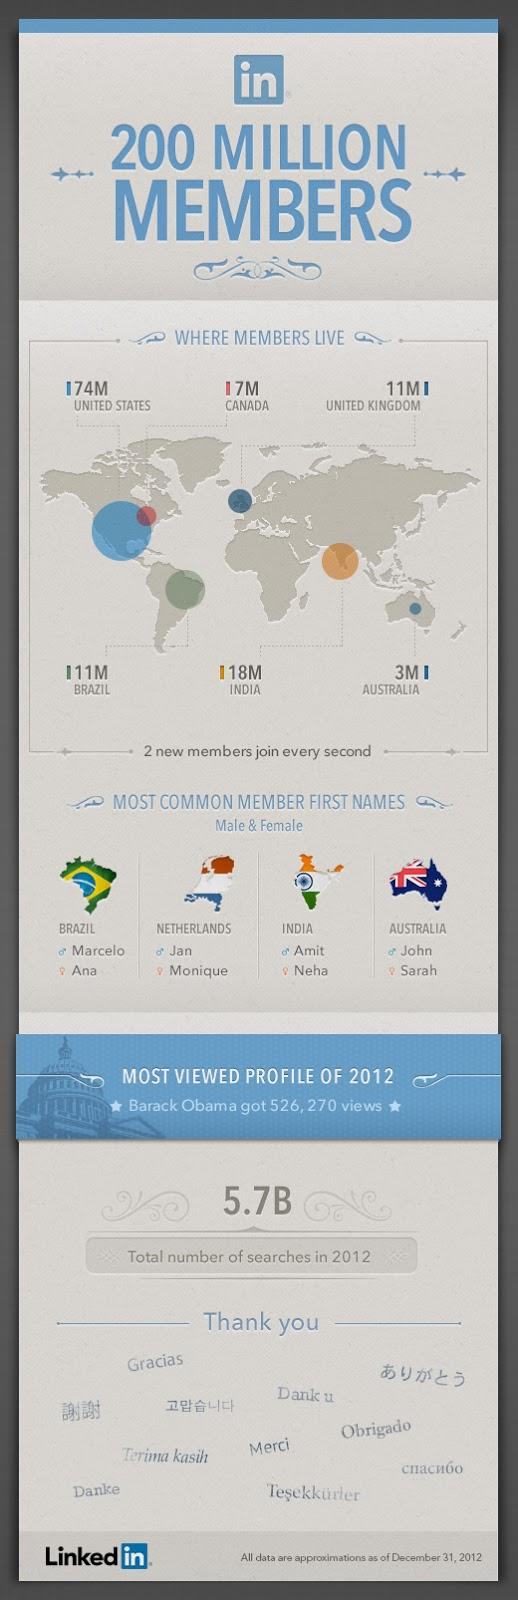Indicate a few pertinent items in this graphic. Neha is the most common first name for females from India. There are approximately 3 million LinkedIn members residing in Australia. A majority of male LinkedIn members in the Netherlands have the first name Jan. Brazilian users commonly use the first name Marcelo. The United States has the highest number of LinkedIn members among all countries. 